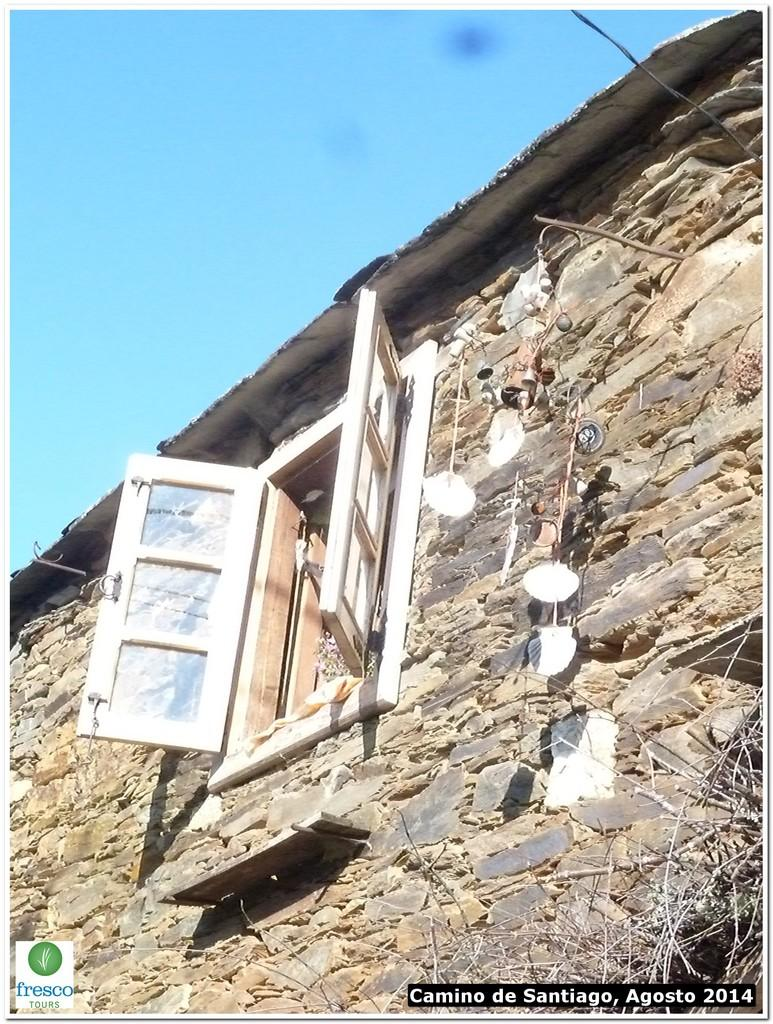What is the main structure visible in the image? There is a wall with windows in the image. What can be seen on the wall? There are objects on the wall. What type of material is present on the right side of the image? There are wooden sticks on the right side of the image. What is visible in the background of the image? The sky is visible in the image. What type of sleet can be seen falling from the sky in the image? There is no sleet visible in the image; the sky is clear. What is the cause of the heat in the image? There is no indication of heat in the image, as the sky is clear and no other sources of heat are mentioned. 